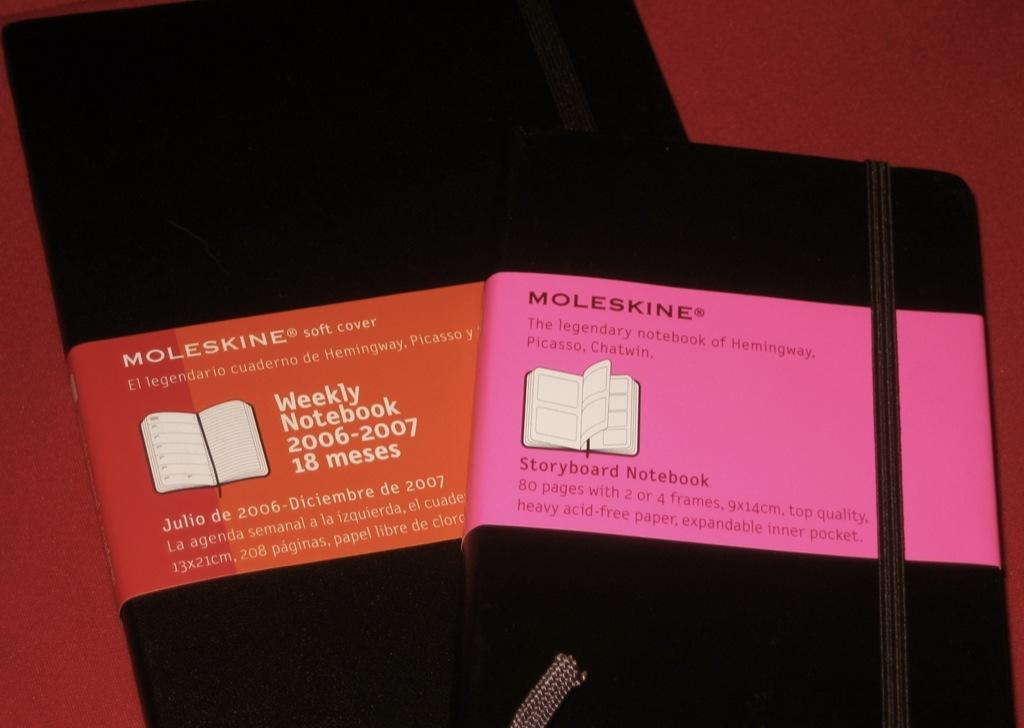<image>
Write a terse but informative summary of the picture. One black Moleskine Weekly Notebook and one black Moleskine Storyboard Notebook. 